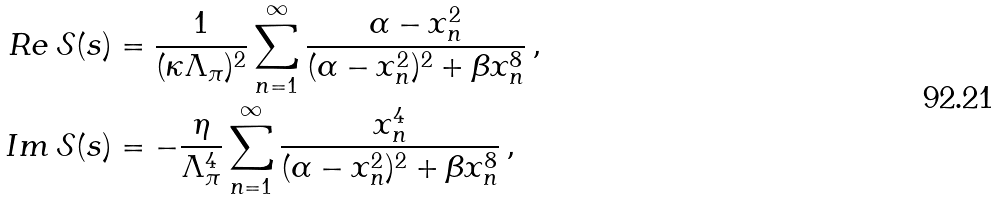Convert formula to latex. <formula><loc_0><loc_0><loc_500><loc_500>R e \, \mathcal { S } ( s ) & = \frac { 1 } { ( \kappa \Lambda _ { \pi } ) ^ { 2 } } \sum _ { n = 1 } ^ { \infty } \frac { \alpha - x _ { n } ^ { 2 } } { ( \alpha - x _ { n } ^ { 2 } ) ^ { 2 } + \beta x _ { n } ^ { 8 } } \, , \\ I m \, \mathcal { S } ( s ) & = - \frac { \eta } { \Lambda _ { \pi } ^ { 4 } } \sum _ { n = 1 } ^ { \infty } \frac { x _ { n } ^ { 4 } } { ( \alpha - x _ { n } ^ { 2 } ) ^ { 2 } + \beta x _ { n } ^ { 8 } } \, ,</formula> 